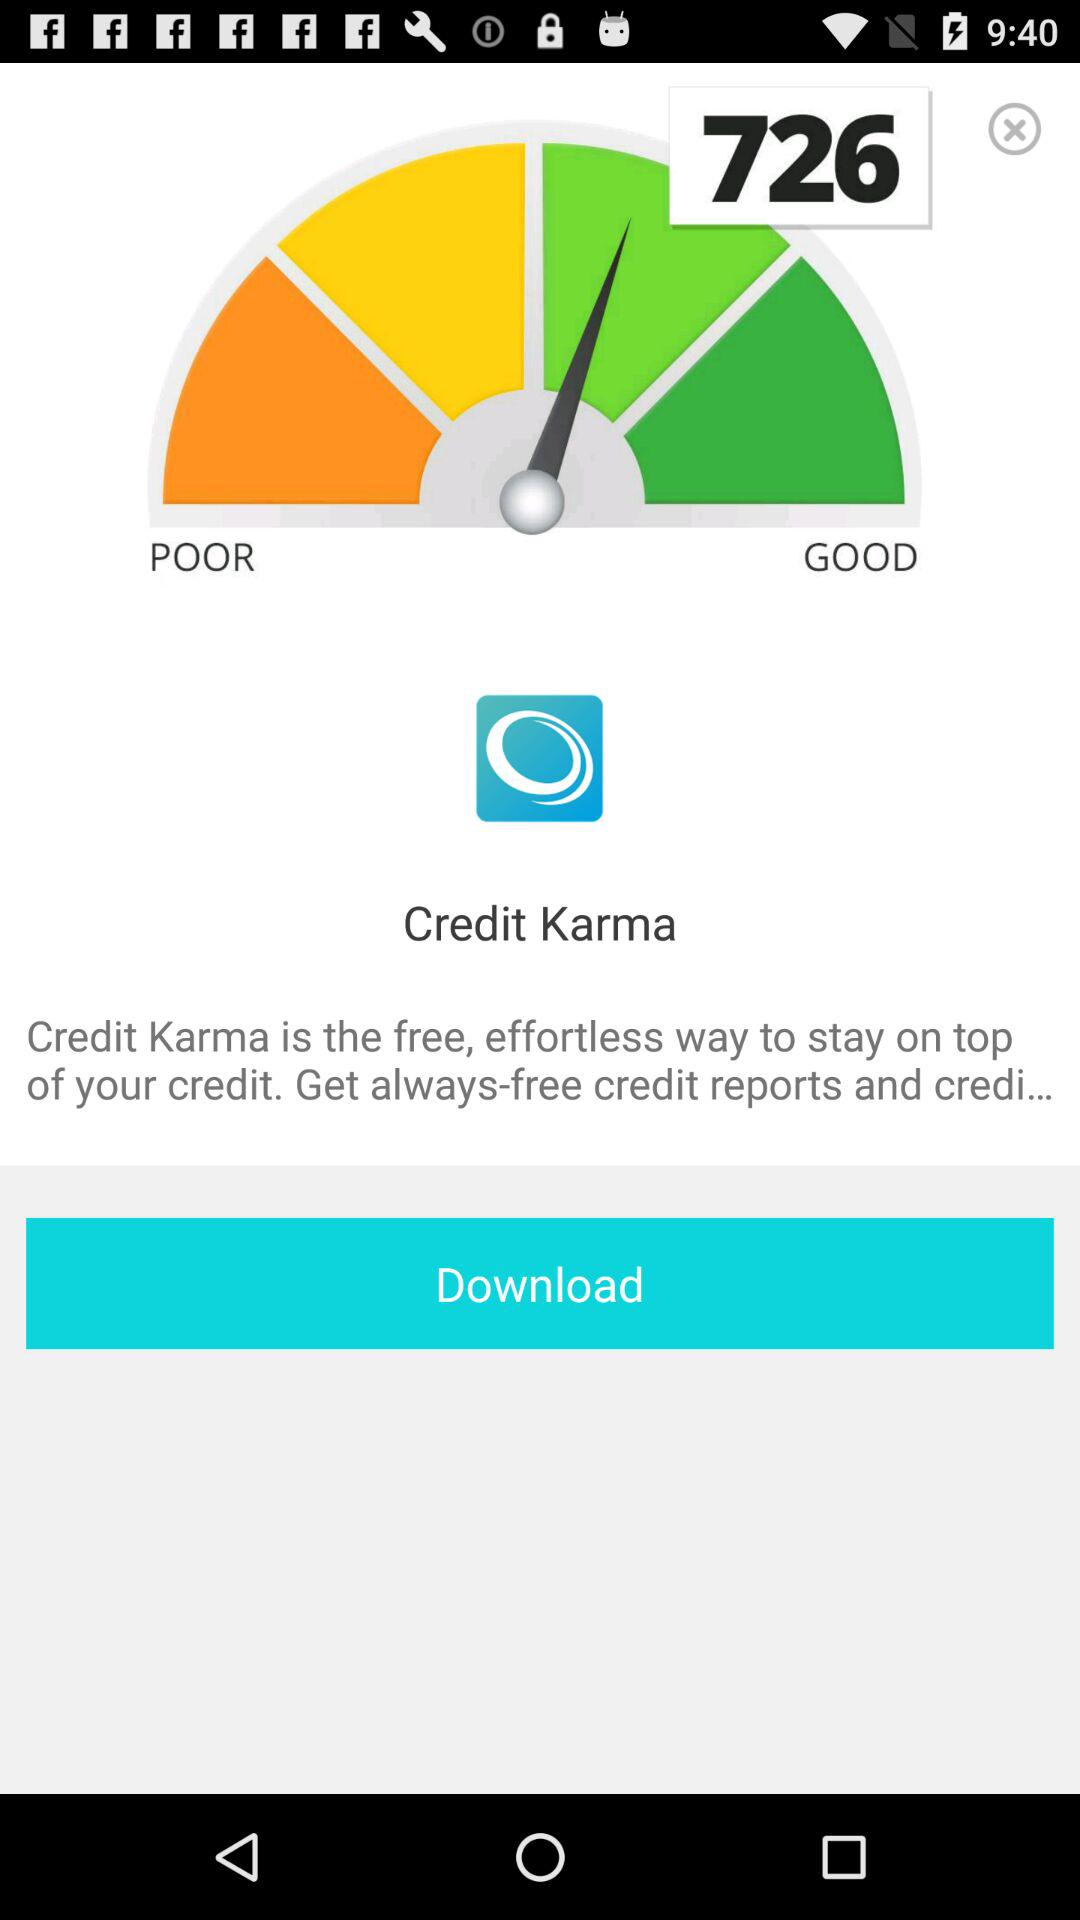What is the name of the application? The name of the application is "Credit Karma". 